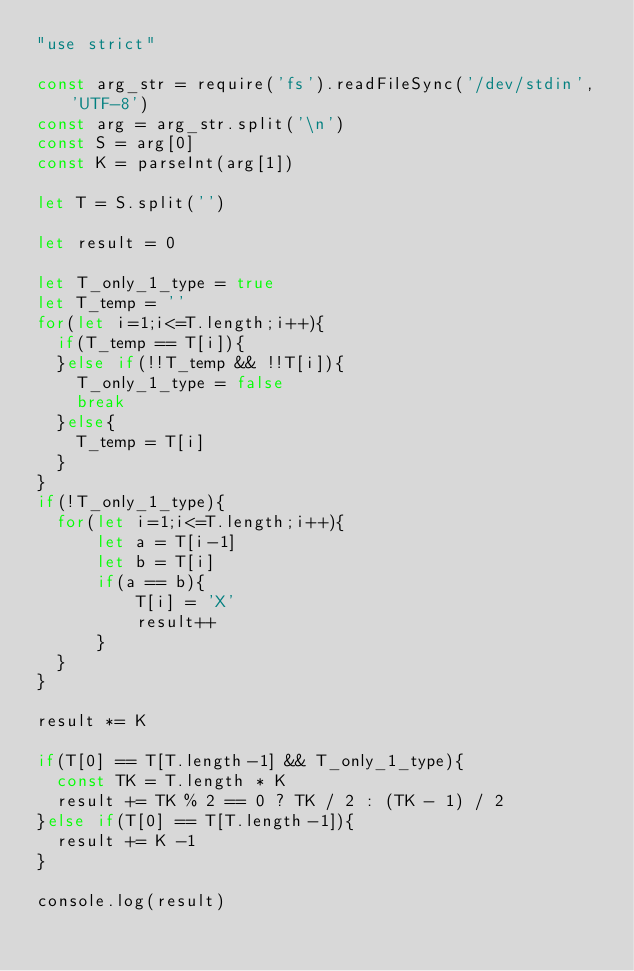Convert code to text. <code><loc_0><loc_0><loc_500><loc_500><_JavaScript_>"use strict"

const arg_str = require('fs').readFileSync('/dev/stdin', 'UTF-8')
const arg = arg_str.split('\n')
const S = arg[0]
const K = parseInt(arg[1])

let T = S.split('')

let result = 0

let T_only_1_type = true
let T_temp = ''
for(let i=1;i<=T.length;i++){
  if(T_temp == T[i]){
  }else if(!!T_temp && !!T[i]){
    T_only_1_type = false
    break
  }else{
    T_temp = T[i]
  }
}
if(!T_only_1_type){
  for(let i=1;i<=T.length;i++){
      let a = T[i-1]
      let b = T[i]
      if(a == b){
          T[i] = 'X'
          result++
      }
  }
}

result *= K

if(T[0] == T[T.length-1] && T_only_1_type){
  const TK = T.length * K
  result += TK % 2 == 0 ? TK / 2 : (TK - 1) / 2
}else if(T[0] == T[T.length-1]){
  result += K -1
}

console.log(result)
</code> 